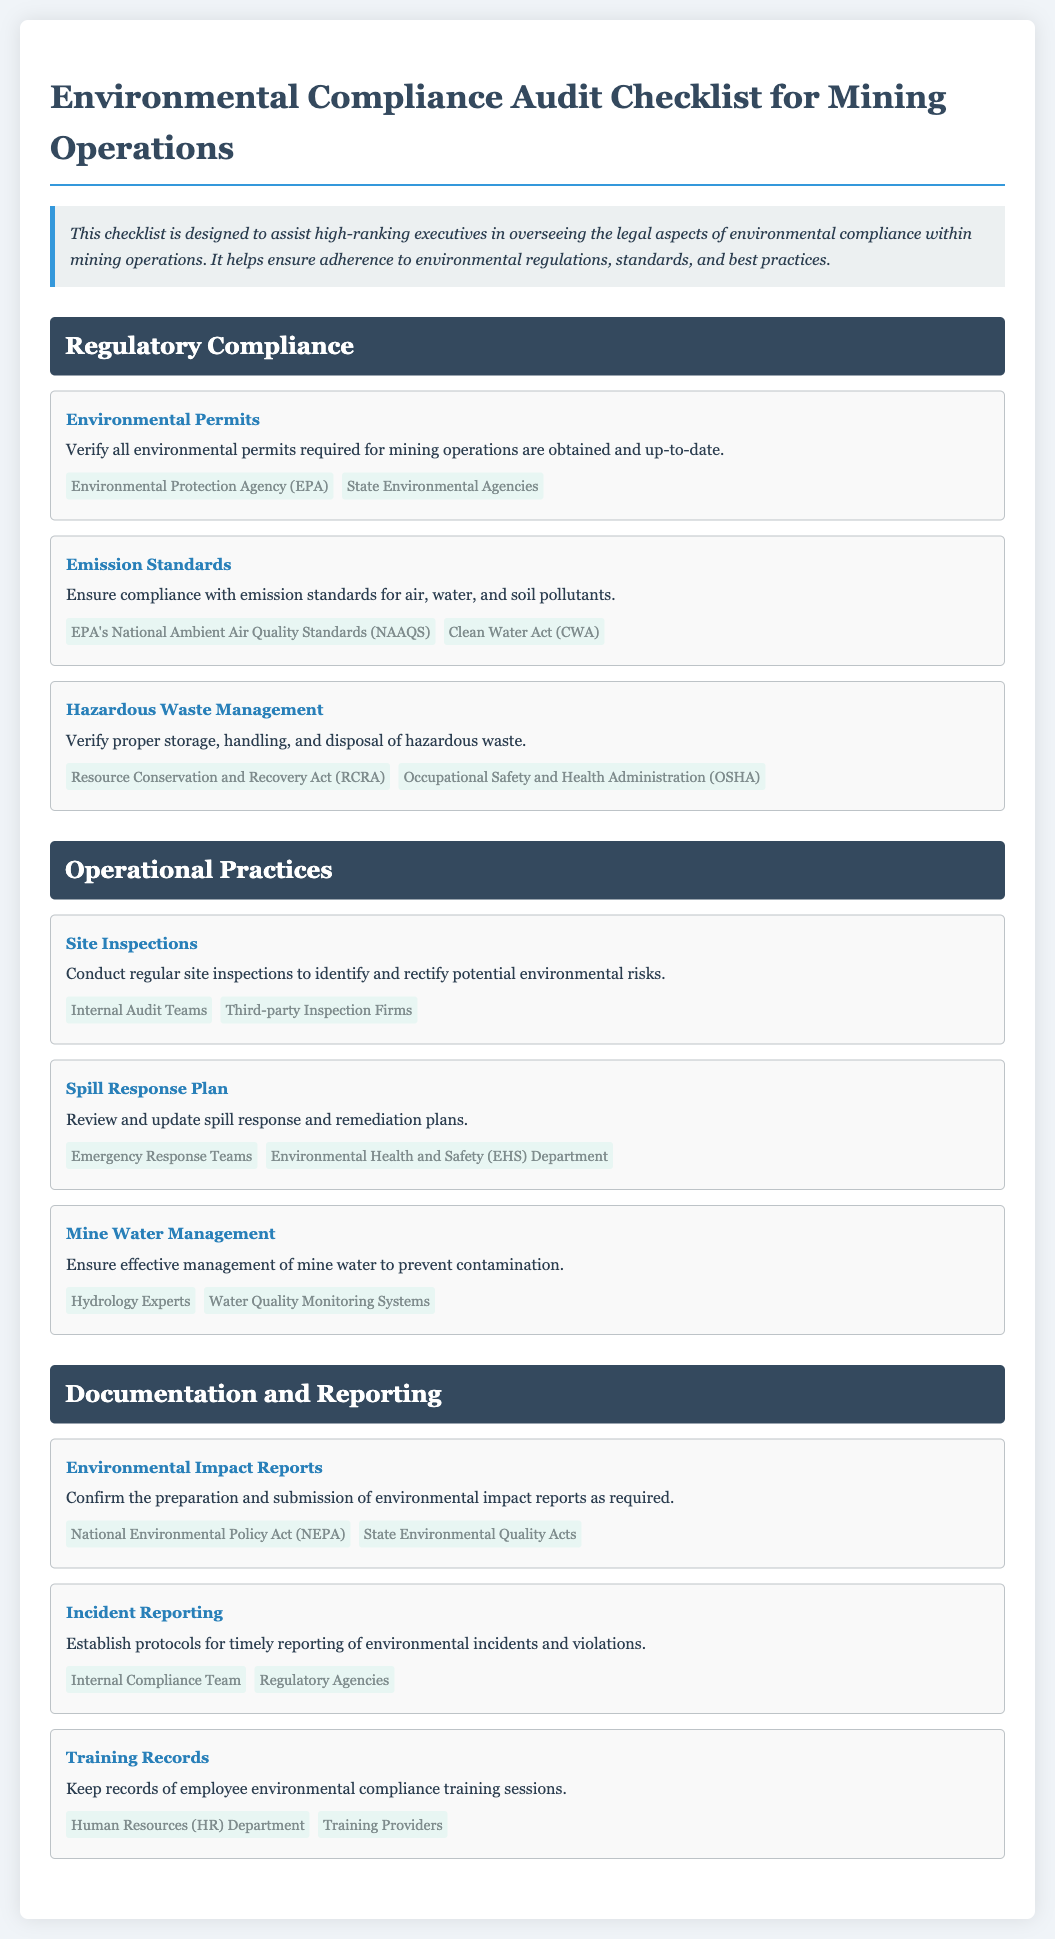what is the title of the checklist? The title of the checklist appears at the top of the document and provides an overview of the content.
Answer: Environmental Compliance Audit Checklist for Mining Operations what is the first item under Regulatory Compliance? The first item in the Regulatory Compliance section highlights the essential environmental permits required for mining operations.
Answer: Environmental Permits which agency is associated with the Hazardous Waste Management item? The document lists the Resource Conservation and Recovery Act as related legislation in the context of hazardous waste management.
Answer: Resource Conservation and Recovery Act (RCRA) how many items are in the Operational Practices section? The Operational Practices section contains three distinct checklist items focused on different practices.
Answer: 3 what is one of the entities mentioned in the spill response plan? The spill response plan lists Emergency Response Teams as a key entity involved in the process.
Answer: Emergency Response Teams what type of documents should be prepared and submitted according to the checklist? The checklist emphasizes the necessity of preparing and submitting environmental impact reports as part of compliance.
Answer: environmental impact reports who is responsible for keeping records of employee environmental compliance training sessions? The Human Resources Department is explicitly mentioned as responsible for maintaining training records.
Answer: Human Resources (HR) Department what is the purpose of site inspections? The purpose of site inspections is to identify and rectify potential environmental risks through regular evaluations of the site.
Answer: identify and rectify potential environmental risks 